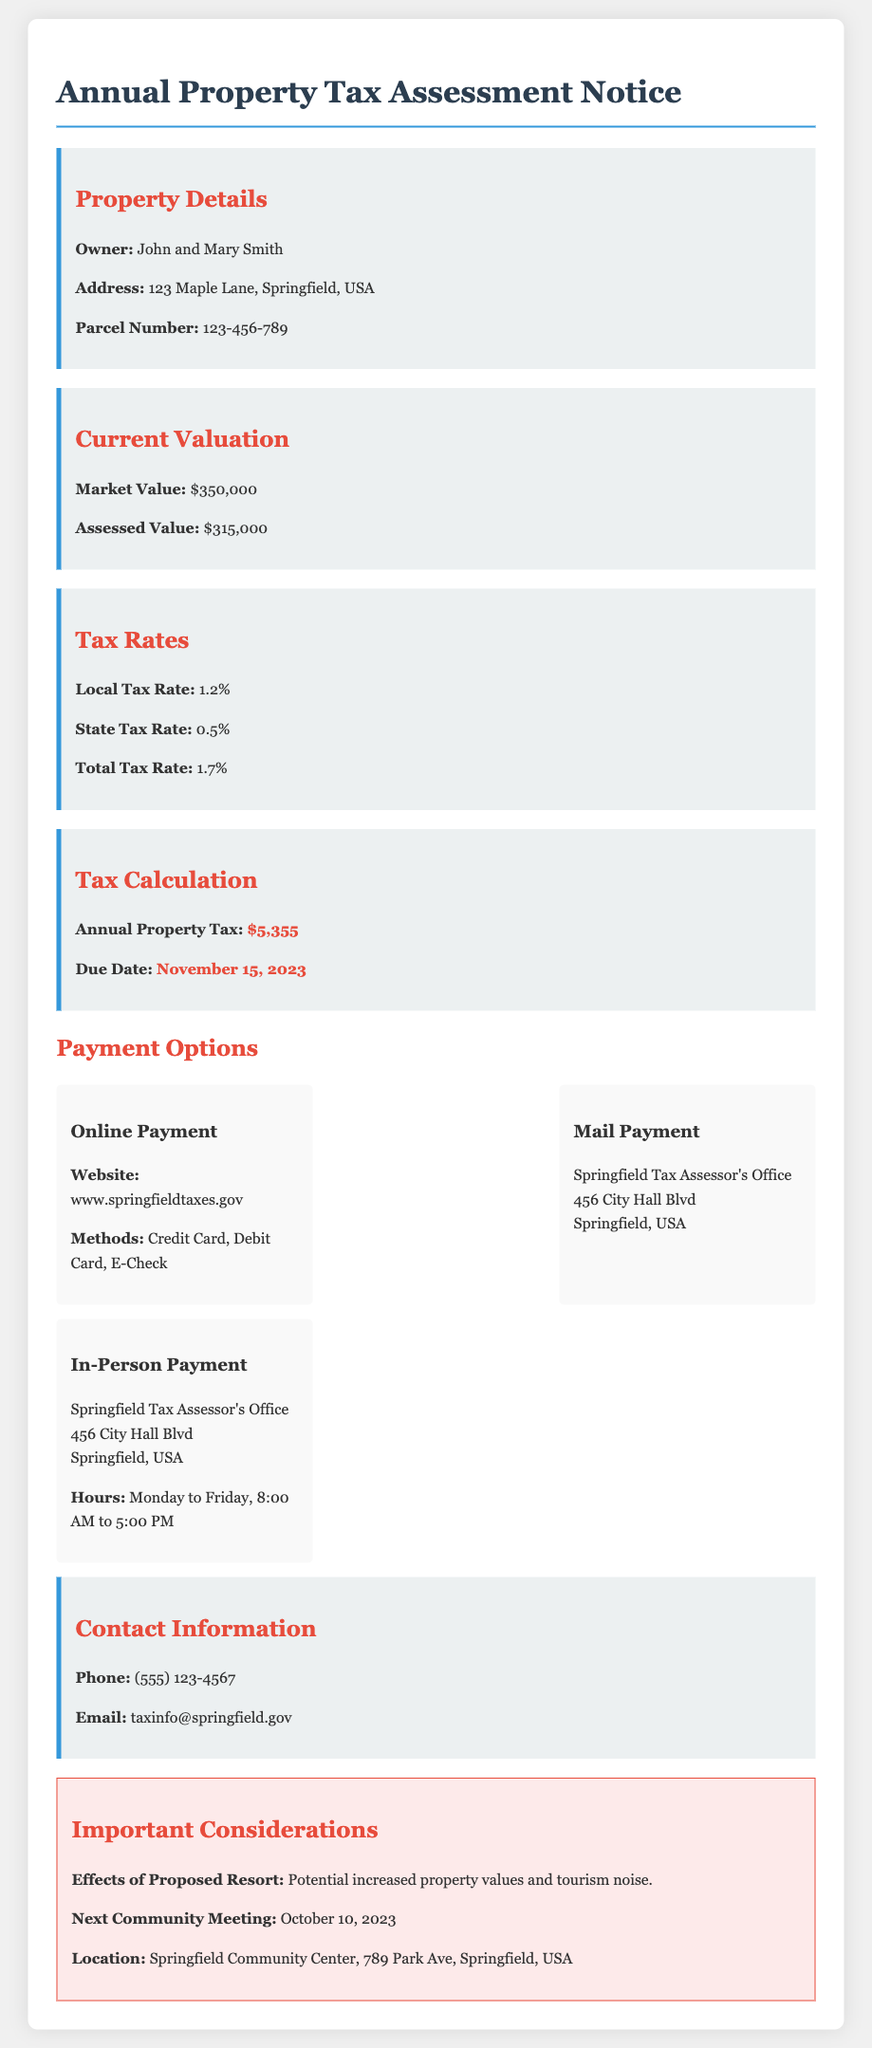What is the market value? The market value is the assessed value of the property listed in the document, which is $350,000.
Answer: $350,000 What is the assessed value? The assessed value is directly stated in the document as the value used for taxation purposes, which is $315,000.
Answer: $315,000 What is the local tax rate? The local tax rate specified in the document is 1.2%.
Answer: 1.2% What is the total property tax due? The total annual property tax calculated in the document is provided explicitly, which is $5,355.
Answer: $5,355 When is the due date for property tax payment? The due date for the property tax payment is highlighted in the document, which is November 15, 2023.
Answer: November 15, 2023 What is one method of online payment? The payment methods listed in the document include Credit Card, which is one of the ways to pay online.
Answer: Credit Card What is the address for mailing payments? The document specifies the mailing address where payments should be sent as Springfield Tax Assessor's Office, 456 City Hall Blvd, Springfield, USA.
Answer: Springfield Tax Assessor's Office, 456 City Hall Blvd, Springfield, USA What are the hours for in-person payments? The hours for in-person payments are listed in the document as Monday to Friday, 8:00 AM to 5:00 PM.
Answer: Monday to Friday, 8:00 AM to 5:00 PM What is one important consideration of the proposed resort? The document notes that the proposed resort could lead to potential increased property values and tourism noise, which affects the residents.
Answer: Potential increased property values and tourism noise 